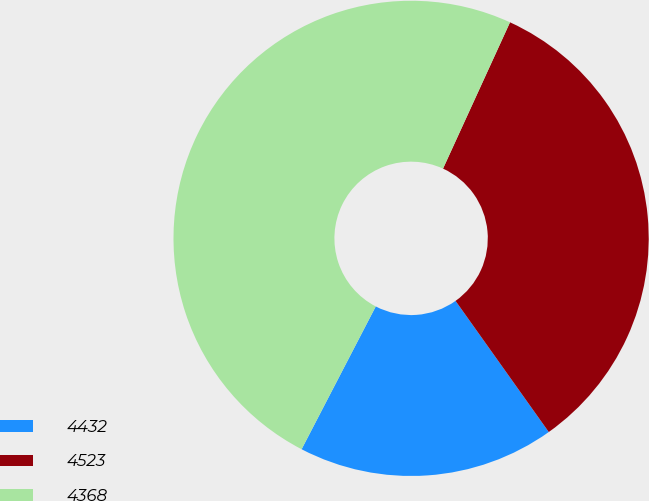<chart> <loc_0><loc_0><loc_500><loc_500><pie_chart><fcel>4432<fcel>4523<fcel>4368<nl><fcel>17.46%<fcel>33.33%<fcel>49.21%<nl></chart> 